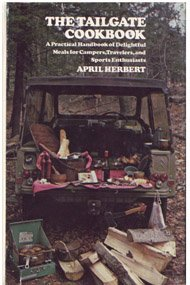Is this book related to Cookbooks, Food & Wine? Yes, this book is squarely in the 'Cookbooks, Food & Wine' category, with a special emphasis on meals that are perfect for tailgating and outdoor get-togethers. 